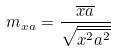Convert formula to latex. <formula><loc_0><loc_0><loc_500><loc_500>m _ { x a } = \frac { \overline { x a } } { \sqrt { \overline { x ^ { 2 } } \overline { a ^ { 2 } } } }</formula> 